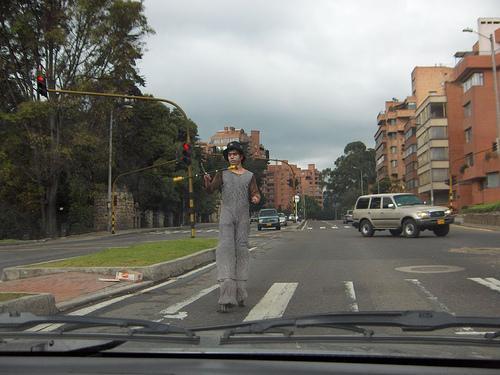How many street lights are there?
Give a very brief answer. 2. How many levels are on the vehicle?
Give a very brief answer. 1. 